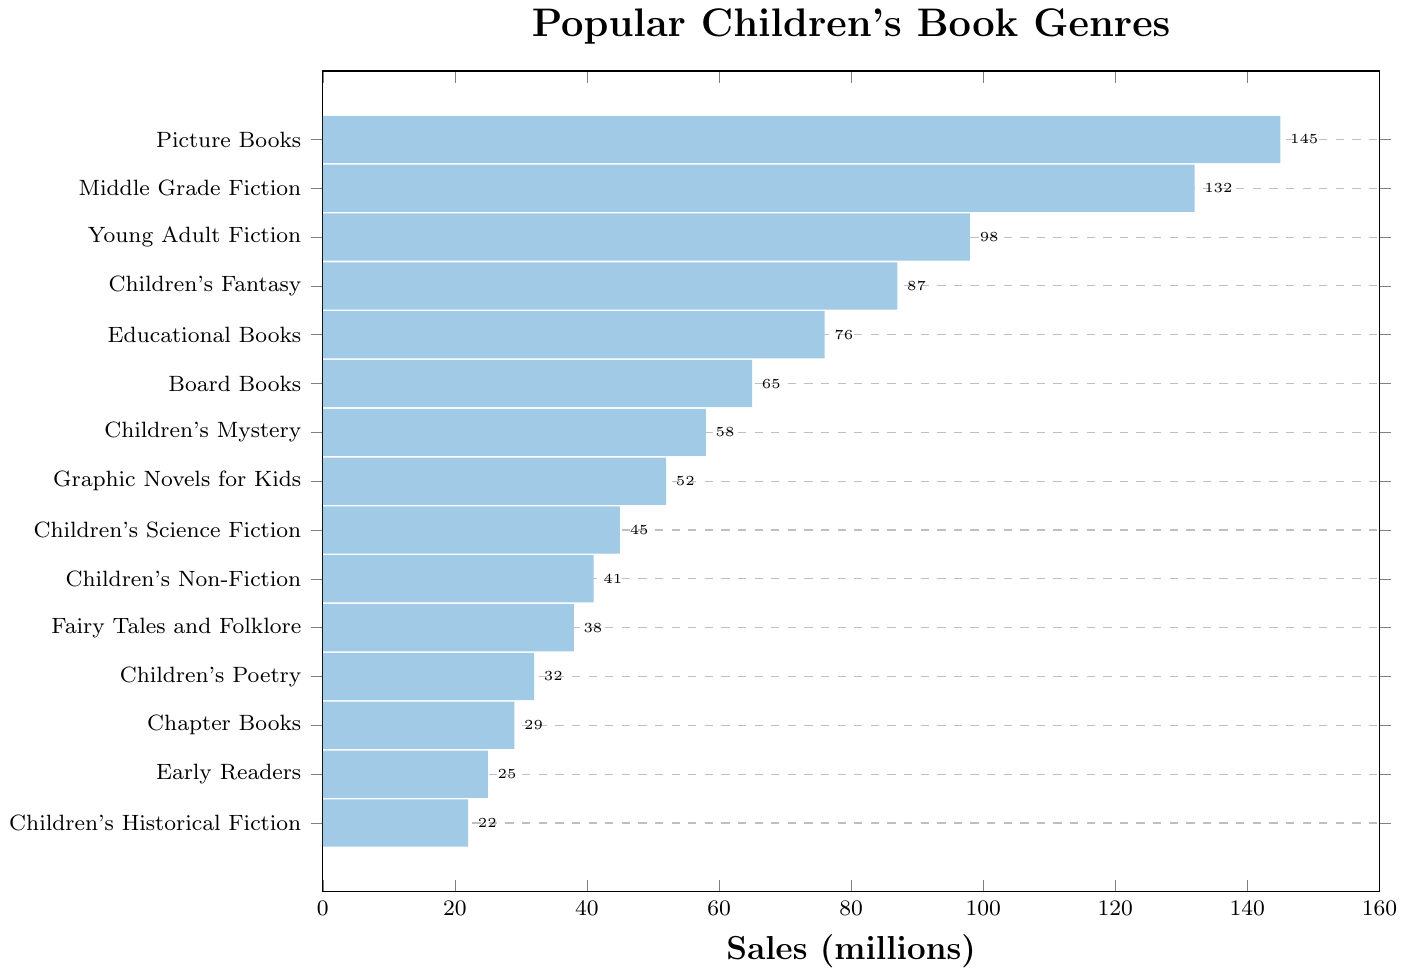Which genre has the highest sales? The figure shows bars representing sales for different book genres. The longest bar represents the highest sales, and it's labeled "Picture Books."
Answer: Picture Books Which genre has the lowest sales? The bar representing the smallest sales figure corresponds to the genre at the bottom of the figure, labeled "Children's Historical Fiction."
Answer: Children's Historical Fiction What is the total sales of "Picture Books" and "Board Books" combined? To find the total, add the sales figures for "Picture Books" and "Board Books." Picture Books have 145 million in sales and Board Books have 65 million, so 145 + 65 = 210 million.
Answer: 210 million How much more were the sales of "Middle Grade Fiction" compared to "Children's Poetry"? Subtract the sales of "Children's Poetry" from "Middle Grade Fiction." Middle Grade Fiction has 132 million in sales and Children's Poetry has 32 million in sales, so 132 - 32 = 100 million.
Answer: 100 million What is the average sales of the top three genres? The top three genres are "Picture Books," "Middle Grade Fiction," and "Young Adult Fiction." Their sales are 145 million, 132 million, and 98 million respectively. Add these together and divide by 3: (145 + 132 + 98)/3 = 375/3 = 125 million.
Answer: 125 million Which genre has sales closest to 50 million? The bar whose length is nearest to the 50 million mark corresponds to "Graphic Novels for Kids" with 52 million in sales.
Answer: Graphic Novels for Kids Is the sum of sales for "Educational Books" and "Children's Science Fiction" greater than the sales of "Young Adult Fiction"? Add the sales of "Educational Books" and "Children's Science Fiction" and compare to "Young Adult Fiction." Educational Books have 76 million and Children's Science Fiction have 45 million in sales, so 76 + 45 = 121 million. Young Adult Fiction has 98 million in sales. Since 121 million > 98 million, the sum is greater.
Answer: Yes By how much do "Children's Non-Fiction" sales differ from "Children's Mystery" sales? Subtract the sales of "Children's Non-Fiction" from "Children's Mystery." Children's Mystery has 58 million and Children's Non-Fiction has 41 million in sales, so 58 - 41 = 17 million.
Answer: 17 million Which genre's sales are exactly 87 million? Refer to the bar with the label "Children's Fantasy," which corresponds to sales of 87 million.
Answer: Children's Fantasy 